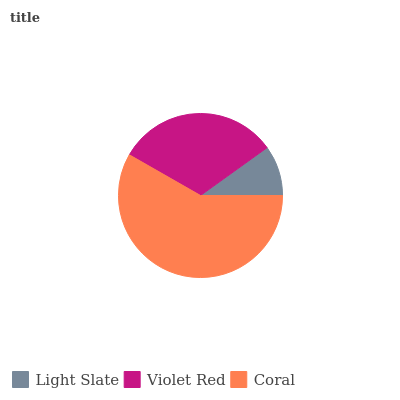Is Light Slate the minimum?
Answer yes or no. Yes. Is Coral the maximum?
Answer yes or no. Yes. Is Violet Red the minimum?
Answer yes or no. No. Is Violet Red the maximum?
Answer yes or no. No. Is Violet Red greater than Light Slate?
Answer yes or no. Yes. Is Light Slate less than Violet Red?
Answer yes or no. Yes. Is Light Slate greater than Violet Red?
Answer yes or no. No. Is Violet Red less than Light Slate?
Answer yes or no. No. Is Violet Red the high median?
Answer yes or no. Yes. Is Violet Red the low median?
Answer yes or no. Yes. Is Coral the high median?
Answer yes or no. No. Is Coral the low median?
Answer yes or no. No. 